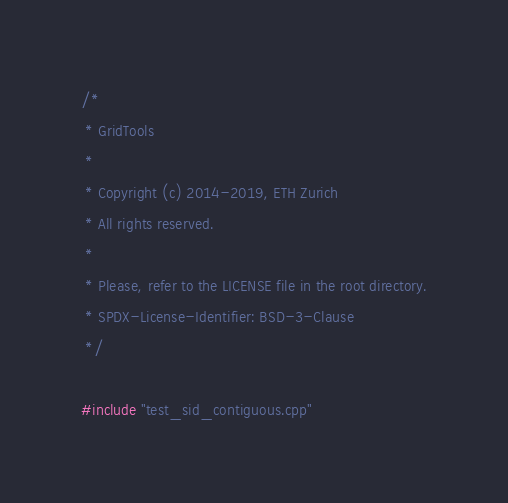<code> <loc_0><loc_0><loc_500><loc_500><_Cuda_>/*
 * GridTools
 *
 * Copyright (c) 2014-2019, ETH Zurich
 * All rights reserved.
 *
 * Please, refer to the LICENSE file in the root directory.
 * SPDX-License-Identifier: BSD-3-Clause
 */

#include "test_sid_contiguous.cpp"
</code> 